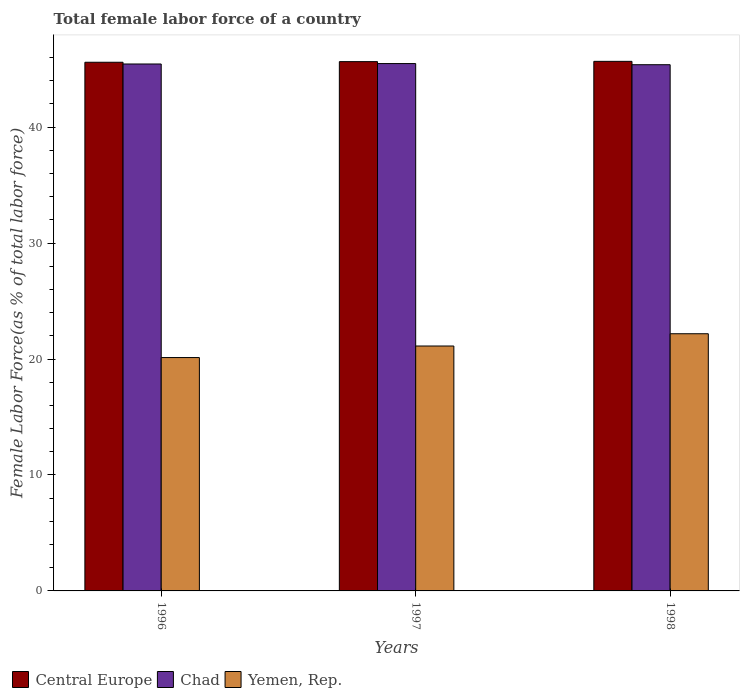How many different coloured bars are there?
Offer a very short reply. 3. How many groups of bars are there?
Make the answer very short. 3. How many bars are there on the 3rd tick from the left?
Your answer should be compact. 3. How many bars are there on the 2nd tick from the right?
Your answer should be compact. 3. What is the percentage of female labor force in Chad in 1996?
Keep it short and to the point. 45.44. Across all years, what is the maximum percentage of female labor force in Yemen, Rep.?
Your answer should be very brief. 22.18. Across all years, what is the minimum percentage of female labor force in Yemen, Rep.?
Your answer should be very brief. 20.13. In which year was the percentage of female labor force in Chad maximum?
Offer a terse response. 1997. In which year was the percentage of female labor force in Central Europe minimum?
Give a very brief answer. 1996. What is the total percentage of female labor force in Yemen, Rep. in the graph?
Your response must be concise. 63.43. What is the difference between the percentage of female labor force in Yemen, Rep. in 1997 and that in 1998?
Provide a succinct answer. -1.06. What is the difference between the percentage of female labor force in Yemen, Rep. in 1997 and the percentage of female labor force in Central Europe in 1998?
Ensure brevity in your answer.  -24.55. What is the average percentage of female labor force in Chad per year?
Give a very brief answer. 45.43. In the year 1996, what is the difference between the percentage of female labor force in Central Europe and percentage of female labor force in Chad?
Give a very brief answer. 0.15. What is the ratio of the percentage of female labor force in Central Europe in 1996 to that in 1998?
Your response must be concise. 1. Is the percentage of female labor force in Central Europe in 1997 less than that in 1998?
Provide a short and direct response. Yes. What is the difference between the highest and the second highest percentage of female labor force in Central Europe?
Make the answer very short. 0.02. What is the difference between the highest and the lowest percentage of female labor force in Central Europe?
Your answer should be compact. 0.08. In how many years, is the percentage of female labor force in Central Europe greater than the average percentage of female labor force in Central Europe taken over all years?
Make the answer very short. 2. What does the 2nd bar from the left in 1998 represents?
Keep it short and to the point. Chad. What does the 3rd bar from the right in 1996 represents?
Your answer should be compact. Central Europe. How many years are there in the graph?
Offer a terse response. 3. How many legend labels are there?
Ensure brevity in your answer.  3. What is the title of the graph?
Your answer should be very brief. Total female labor force of a country. What is the label or title of the X-axis?
Your answer should be very brief. Years. What is the label or title of the Y-axis?
Your answer should be very brief. Female Labor Force(as % of total labor force). What is the Female Labor Force(as % of total labor force) in Central Europe in 1996?
Provide a short and direct response. 45.59. What is the Female Labor Force(as % of total labor force) of Chad in 1996?
Give a very brief answer. 45.44. What is the Female Labor Force(as % of total labor force) of Yemen, Rep. in 1996?
Provide a short and direct response. 20.13. What is the Female Labor Force(as % of total labor force) in Central Europe in 1997?
Your answer should be compact. 45.65. What is the Female Labor Force(as % of total labor force) in Chad in 1997?
Make the answer very short. 45.48. What is the Female Labor Force(as % of total labor force) of Yemen, Rep. in 1997?
Provide a succinct answer. 21.12. What is the Female Labor Force(as % of total labor force) in Central Europe in 1998?
Your answer should be very brief. 45.67. What is the Female Labor Force(as % of total labor force) in Chad in 1998?
Give a very brief answer. 45.38. What is the Female Labor Force(as % of total labor force) in Yemen, Rep. in 1998?
Offer a terse response. 22.18. Across all years, what is the maximum Female Labor Force(as % of total labor force) in Central Europe?
Keep it short and to the point. 45.67. Across all years, what is the maximum Female Labor Force(as % of total labor force) of Chad?
Keep it short and to the point. 45.48. Across all years, what is the maximum Female Labor Force(as % of total labor force) of Yemen, Rep.?
Give a very brief answer. 22.18. Across all years, what is the minimum Female Labor Force(as % of total labor force) of Central Europe?
Give a very brief answer. 45.59. Across all years, what is the minimum Female Labor Force(as % of total labor force) in Chad?
Your answer should be compact. 45.38. Across all years, what is the minimum Female Labor Force(as % of total labor force) of Yemen, Rep.?
Keep it short and to the point. 20.13. What is the total Female Labor Force(as % of total labor force) in Central Europe in the graph?
Give a very brief answer. 136.91. What is the total Female Labor Force(as % of total labor force) of Chad in the graph?
Make the answer very short. 136.3. What is the total Female Labor Force(as % of total labor force) of Yemen, Rep. in the graph?
Your response must be concise. 63.43. What is the difference between the Female Labor Force(as % of total labor force) in Central Europe in 1996 and that in 1997?
Keep it short and to the point. -0.05. What is the difference between the Female Labor Force(as % of total labor force) of Chad in 1996 and that in 1997?
Give a very brief answer. -0.04. What is the difference between the Female Labor Force(as % of total labor force) of Yemen, Rep. in 1996 and that in 1997?
Ensure brevity in your answer.  -1. What is the difference between the Female Labor Force(as % of total labor force) of Central Europe in 1996 and that in 1998?
Provide a succinct answer. -0.08. What is the difference between the Female Labor Force(as % of total labor force) in Chad in 1996 and that in 1998?
Provide a succinct answer. 0.06. What is the difference between the Female Labor Force(as % of total labor force) in Yemen, Rep. in 1996 and that in 1998?
Your response must be concise. -2.05. What is the difference between the Female Labor Force(as % of total labor force) of Central Europe in 1997 and that in 1998?
Make the answer very short. -0.02. What is the difference between the Female Labor Force(as % of total labor force) in Chad in 1997 and that in 1998?
Offer a terse response. 0.1. What is the difference between the Female Labor Force(as % of total labor force) in Yemen, Rep. in 1997 and that in 1998?
Keep it short and to the point. -1.06. What is the difference between the Female Labor Force(as % of total labor force) of Central Europe in 1996 and the Female Labor Force(as % of total labor force) of Chad in 1997?
Provide a succinct answer. 0.11. What is the difference between the Female Labor Force(as % of total labor force) of Central Europe in 1996 and the Female Labor Force(as % of total labor force) of Yemen, Rep. in 1997?
Your answer should be compact. 24.47. What is the difference between the Female Labor Force(as % of total labor force) of Chad in 1996 and the Female Labor Force(as % of total labor force) of Yemen, Rep. in 1997?
Offer a terse response. 24.32. What is the difference between the Female Labor Force(as % of total labor force) of Central Europe in 1996 and the Female Labor Force(as % of total labor force) of Chad in 1998?
Your response must be concise. 0.21. What is the difference between the Female Labor Force(as % of total labor force) of Central Europe in 1996 and the Female Labor Force(as % of total labor force) of Yemen, Rep. in 1998?
Keep it short and to the point. 23.41. What is the difference between the Female Labor Force(as % of total labor force) of Chad in 1996 and the Female Labor Force(as % of total labor force) of Yemen, Rep. in 1998?
Your response must be concise. 23.26. What is the difference between the Female Labor Force(as % of total labor force) in Central Europe in 1997 and the Female Labor Force(as % of total labor force) in Chad in 1998?
Provide a succinct answer. 0.27. What is the difference between the Female Labor Force(as % of total labor force) in Central Europe in 1997 and the Female Labor Force(as % of total labor force) in Yemen, Rep. in 1998?
Your answer should be compact. 23.47. What is the difference between the Female Labor Force(as % of total labor force) of Chad in 1997 and the Female Labor Force(as % of total labor force) of Yemen, Rep. in 1998?
Ensure brevity in your answer.  23.3. What is the average Female Labor Force(as % of total labor force) of Central Europe per year?
Your response must be concise. 45.64. What is the average Female Labor Force(as % of total labor force) of Chad per year?
Ensure brevity in your answer.  45.43. What is the average Female Labor Force(as % of total labor force) of Yemen, Rep. per year?
Keep it short and to the point. 21.14. In the year 1996, what is the difference between the Female Labor Force(as % of total labor force) in Central Europe and Female Labor Force(as % of total labor force) in Chad?
Give a very brief answer. 0.15. In the year 1996, what is the difference between the Female Labor Force(as % of total labor force) of Central Europe and Female Labor Force(as % of total labor force) of Yemen, Rep.?
Provide a short and direct response. 25.47. In the year 1996, what is the difference between the Female Labor Force(as % of total labor force) of Chad and Female Labor Force(as % of total labor force) of Yemen, Rep.?
Keep it short and to the point. 25.32. In the year 1997, what is the difference between the Female Labor Force(as % of total labor force) in Central Europe and Female Labor Force(as % of total labor force) in Chad?
Ensure brevity in your answer.  0.17. In the year 1997, what is the difference between the Female Labor Force(as % of total labor force) in Central Europe and Female Labor Force(as % of total labor force) in Yemen, Rep.?
Provide a short and direct response. 24.52. In the year 1997, what is the difference between the Female Labor Force(as % of total labor force) of Chad and Female Labor Force(as % of total labor force) of Yemen, Rep.?
Keep it short and to the point. 24.36. In the year 1998, what is the difference between the Female Labor Force(as % of total labor force) in Central Europe and Female Labor Force(as % of total labor force) in Chad?
Offer a terse response. 0.29. In the year 1998, what is the difference between the Female Labor Force(as % of total labor force) of Central Europe and Female Labor Force(as % of total labor force) of Yemen, Rep.?
Keep it short and to the point. 23.49. In the year 1998, what is the difference between the Female Labor Force(as % of total labor force) of Chad and Female Labor Force(as % of total labor force) of Yemen, Rep.?
Make the answer very short. 23.2. What is the ratio of the Female Labor Force(as % of total labor force) of Central Europe in 1996 to that in 1997?
Offer a very short reply. 1. What is the ratio of the Female Labor Force(as % of total labor force) of Chad in 1996 to that in 1997?
Provide a short and direct response. 1. What is the ratio of the Female Labor Force(as % of total labor force) of Yemen, Rep. in 1996 to that in 1997?
Offer a terse response. 0.95. What is the ratio of the Female Labor Force(as % of total labor force) in Chad in 1996 to that in 1998?
Give a very brief answer. 1. What is the ratio of the Female Labor Force(as % of total labor force) in Yemen, Rep. in 1996 to that in 1998?
Give a very brief answer. 0.91. What is the ratio of the Female Labor Force(as % of total labor force) in Central Europe in 1997 to that in 1998?
Your answer should be compact. 1. What is the ratio of the Female Labor Force(as % of total labor force) in Chad in 1997 to that in 1998?
Keep it short and to the point. 1. What is the ratio of the Female Labor Force(as % of total labor force) in Yemen, Rep. in 1997 to that in 1998?
Give a very brief answer. 0.95. What is the difference between the highest and the second highest Female Labor Force(as % of total labor force) of Central Europe?
Your response must be concise. 0.02. What is the difference between the highest and the second highest Female Labor Force(as % of total labor force) of Chad?
Provide a succinct answer. 0.04. What is the difference between the highest and the second highest Female Labor Force(as % of total labor force) in Yemen, Rep.?
Provide a succinct answer. 1.06. What is the difference between the highest and the lowest Female Labor Force(as % of total labor force) in Central Europe?
Offer a terse response. 0.08. What is the difference between the highest and the lowest Female Labor Force(as % of total labor force) of Chad?
Give a very brief answer. 0.1. What is the difference between the highest and the lowest Female Labor Force(as % of total labor force) of Yemen, Rep.?
Ensure brevity in your answer.  2.05. 